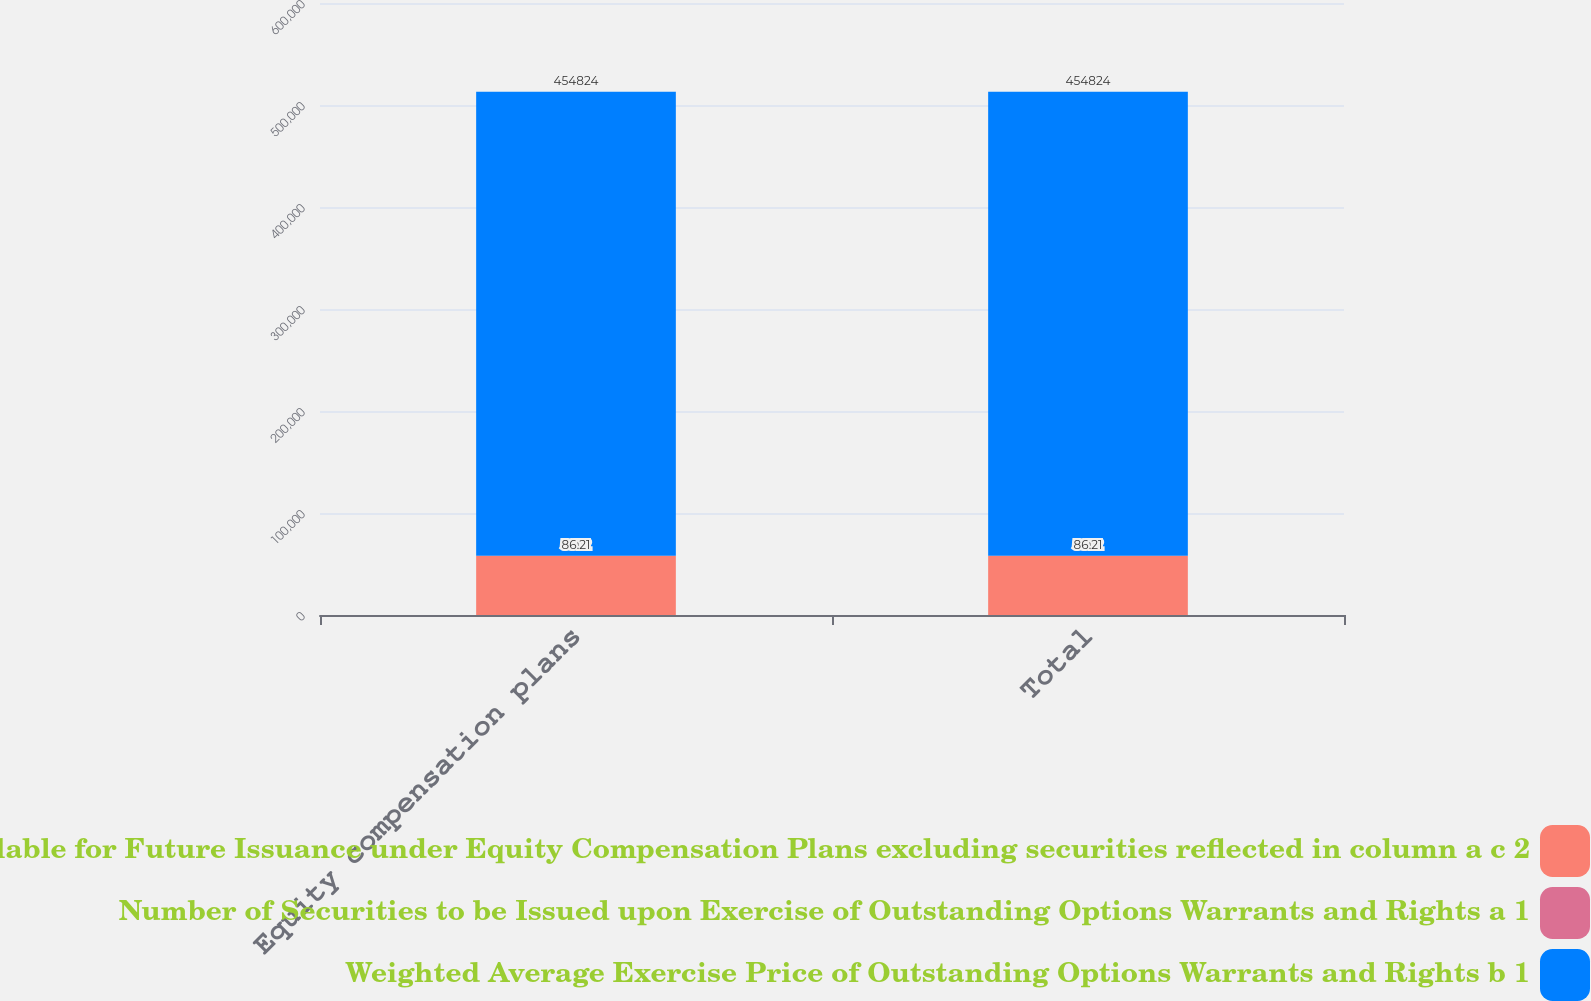<chart> <loc_0><loc_0><loc_500><loc_500><stacked_bar_chart><ecel><fcel>Equity compensation plans<fcel>Total<nl><fcel>Number of Securities Remaining Available for Future Issuance under Equity Compensation Plans excluding securities reflected in column a c 2<fcel>58112<fcel>58112<nl><fcel>Number of Securities to be Issued upon Exercise of Outstanding Options Warrants and Rights a 1<fcel>86.21<fcel>86.21<nl><fcel>Weighted Average Exercise Price of Outstanding Options Warrants and Rights b 1<fcel>454824<fcel>454824<nl></chart> 